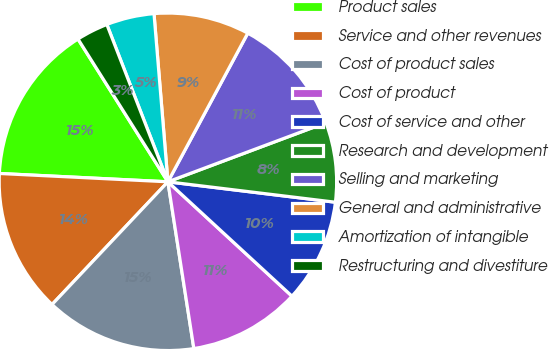<chart> <loc_0><loc_0><loc_500><loc_500><pie_chart><fcel>Product sales<fcel>Service and other revenues<fcel>Cost of product sales<fcel>Cost of product<fcel>Cost of service and other<fcel>Research and development<fcel>Selling and marketing<fcel>General and administrative<fcel>Amortization of intangible<fcel>Restructuring and divestiture<nl><fcel>15.27%<fcel>13.74%<fcel>14.5%<fcel>10.69%<fcel>9.92%<fcel>7.63%<fcel>11.45%<fcel>9.16%<fcel>4.58%<fcel>3.05%<nl></chart> 